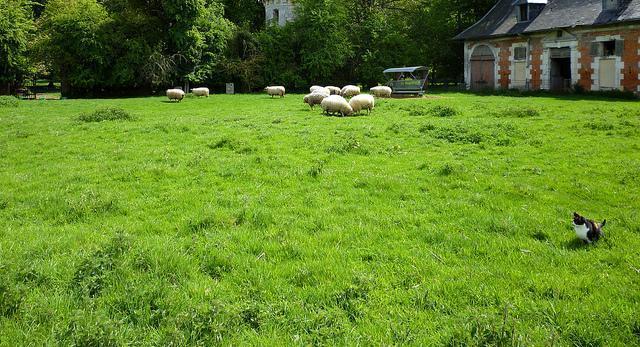How many cats are there?
Give a very brief answer. 1. How many houses are in this picture?
Give a very brief answer. 2. 